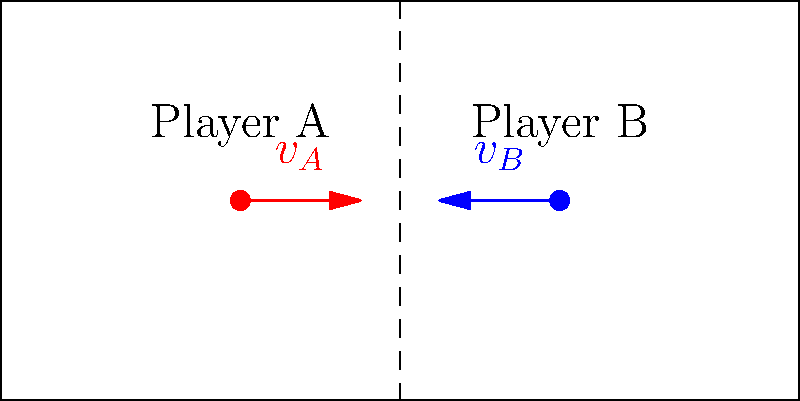In a youth football game, Player A (mass $m_A = 60$ kg) is running towards Player B (mass $m_B = 65$ kg) to make a tackle. Player A is moving with a velocity $v_A = 5$ m/s, while Player B is running in the opposite direction with a velocity $v_B = 3$ m/s. Assuming a perfectly inelastic collision during the tackle, calculate the magnitude of the average force required to bring both players to a stop within a distance of 0.5 meters after contact. To solve this problem, we'll follow these steps:

1) First, calculate the relative velocity of the players:
   $v_{rel} = v_A + v_B = 5 + 3 = 8$ m/s

2) Find the total mass of both players:
   $m_{total} = m_A + m_B = 60 + 65 = 125$ kg

3) Calculate the initial momentum of the system:
   $p_i = m_{total} \cdot v_{rel} = 125 \cdot 8 = 1000$ kg⋅m/s

4) The final momentum after the tackle is zero (they come to a stop).

5) Use the impulse-momentum theorem:
   $F \cdot \Delta t = \Delta p = p_f - p_i = 0 - 1000 = -1000$ N⋅s

6) We need to find $\Delta t$. We can use the equation of motion:
   $d = \frac{1}{2}a\Delta t^2$, where $d = 0.5$ m (given stopping distance)
   
   Also, $a = \frac{v_f - v_i}{\Delta t} = \frac{0 - 8}{\Delta t} = -\frac{8}{\Delta t}$

   Substituting: $0.5 = \frac{1}{2} \cdot (-\frac{8}{\Delta t}) \cdot \Delta t^2$

   Solving for $\Delta t$: $\Delta t = \frac{0.5}{\sqrt{2}}$ s

7) Now we can calculate the force:
   $F = \frac{\Delta p}{\Delta t} = \frac{1000}{\frac{0.5}{\sqrt{2}}} = 1000 \cdot \frac{2\sqrt{2}}{1} = 2000\sqrt{2}$ N

Therefore, the magnitude of the average force required is $2000\sqrt{2}$ N.
Answer: $2000\sqrt{2}$ N 